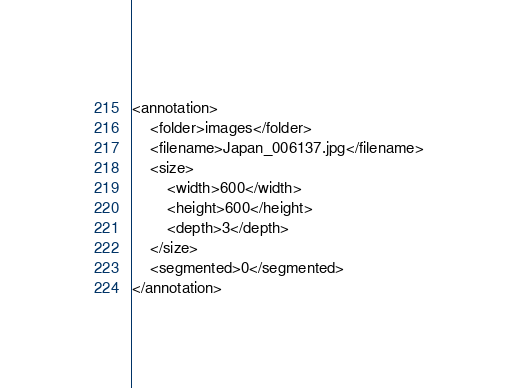Convert code to text. <code><loc_0><loc_0><loc_500><loc_500><_XML_><annotation>
	<folder>images</folder>
	<filename>Japan_006137.jpg</filename>
	<size>
		<width>600</width>
		<height>600</height>
		<depth>3</depth>
	</size>
	<segmented>0</segmented>
</annotation></code> 